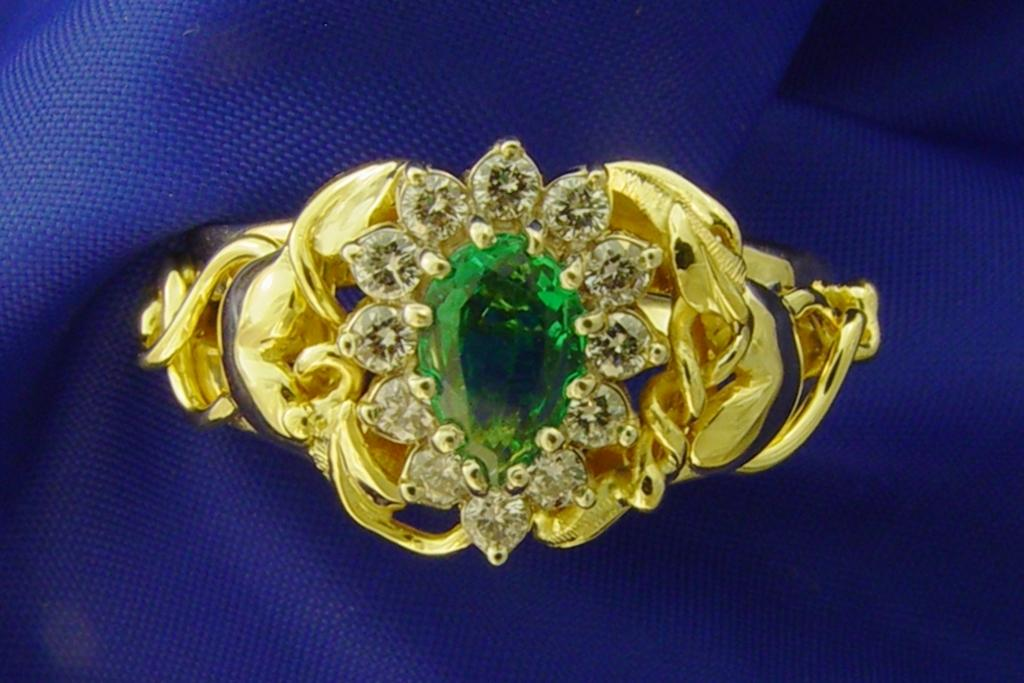What is the main object in the image? There is a ring in the image. What is unique about the ring? The ring has stones on it. What type of question is being asked by the spy in the image? There is no indication of a spy or any questions being asked in the image; it only features a ring with stones on it. 